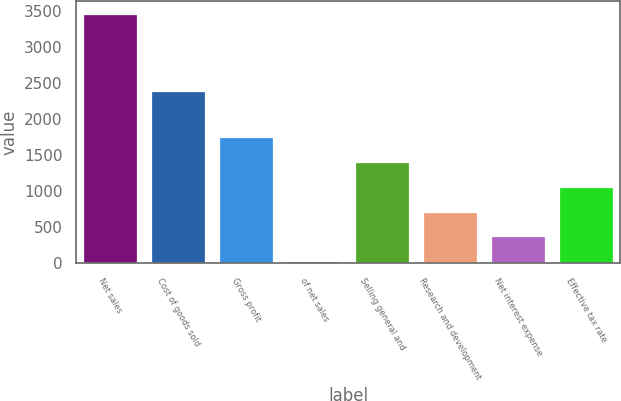<chart> <loc_0><loc_0><loc_500><loc_500><bar_chart><fcel>Net sales<fcel>Cost of goods sold<fcel>Gross profit<fcel>of net sales<fcel>Selling general and<fcel>Research and development<fcel>Net interest expense<fcel>Effective tax rate<nl><fcel>3456.7<fcel>2383<fcel>1743.9<fcel>31.1<fcel>1401.34<fcel>716.22<fcel>373.66<fcel>1058.78<nl></chart> 